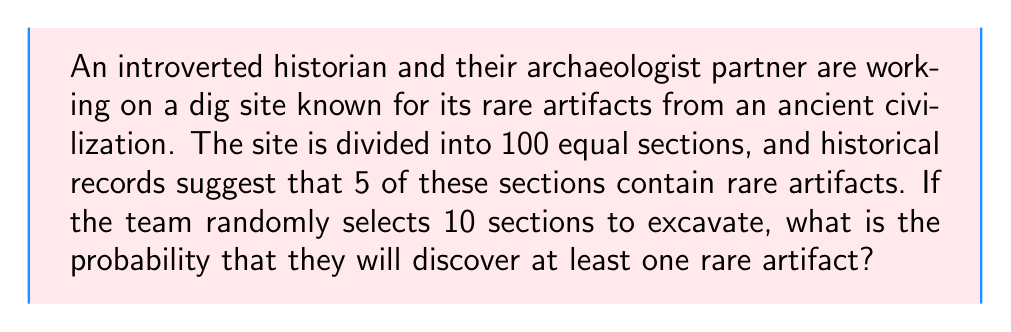Can you solve this math problem? To solve this problem, we'll use the complement method, which involves calculating the probability of not finding any rare artifacts and then subtracting that from 1.

Step 1: Calculate the probability of not selecting a section with a rare artifact in a single selection.
$P(\text{no rare artifact}) = \frac{95}{100} = 0.95$

Step 2: Calculate the probability of not finding any rare artifacts in all 10 selections.
$P(\text{no rare artifacts in 10 selections}) = (0.95)^{10}$

Step 3: Calculate the probability of finding at least one rare artifact by subtracting the probability of finding no rare artifacts from 1.
$P(\text{at least one rare artifact}) = 1 - P(\text{no rare artifacts in 10 selections})$
$= 1 - (0.95)^{10}$

Step 4: Evaluate the expression.
$= 1 - 0.5987369392383789$
$= 0.4012630607616211$

Therefore, the probability of discovering at least one rare artifact when excavating 10 randomly selected sections is approximately 0.4013 or 40.13%.
Answer: The probability of discovering at least one rare artifact is approximately 0.4013 or 40.13%. 